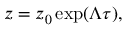Convert formula to latex. <formula><loc_0><loc_0><loc_500><loc_500>z = z _ { 0 } \exp ( \Lambda \tau ) ,</formula> 